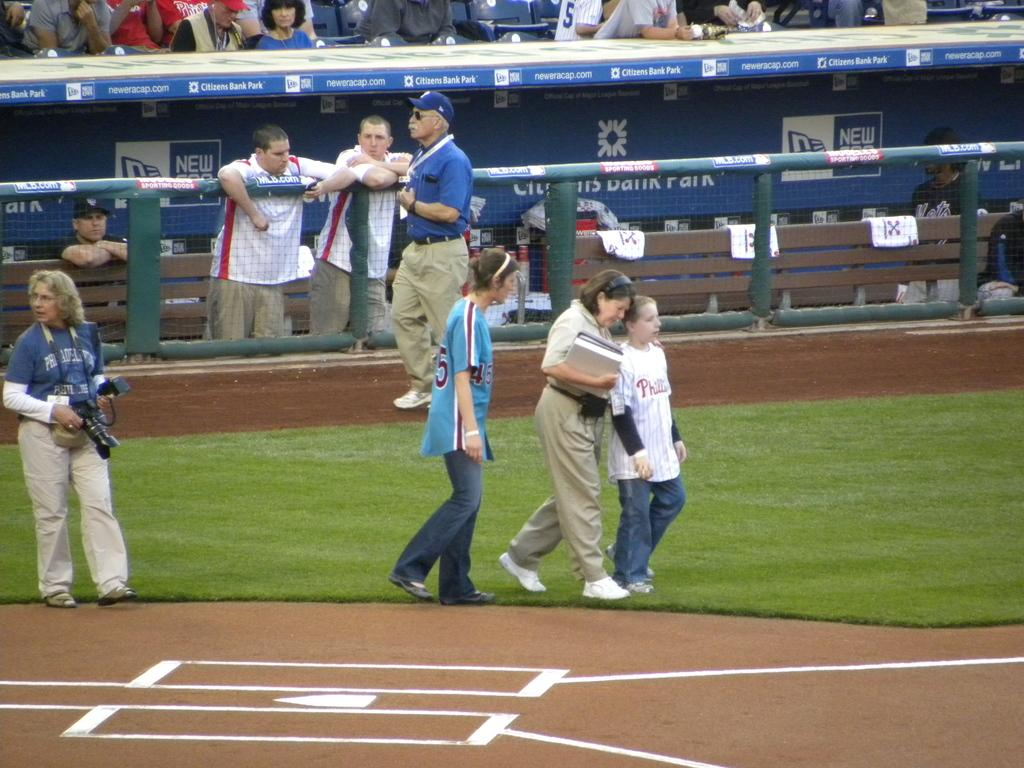<image>
Write a terse but informative summary of the picture. the words citizens bank park are on the top of a dugout 